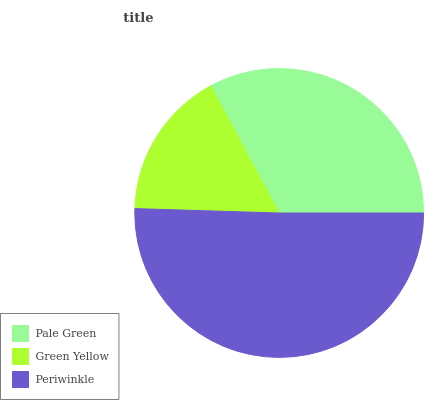Is Green Yellow the minimum?
Answer yes or no. Yes. Is Periwinkle the maximum?
Answer yes or no. Yes. Is Periwinkle the minimum?
Answer yes or no. No. Is Green Yellow the maximum?
Answer yes or no. No. Is Periwinkle greater than Green Yellow?
Answer yes or no. Yes. Is Green Yellow less than Periwinkle?
Answer yes or no. Yes. Is Green Yellow greater than Periwinkle?
Answer yes or no. No. Is Periwinkle less than Green Yellow?
Answer yes or no. No. Is Pale Green the high median?
Answer yes or no. Yes. Is Pale Green the low median?
Answer yes or no. Yes. Is Green Yellow the high median?
Answer yes or no. No. Is Green Yellow the low median?
Answer yes or no. No. 